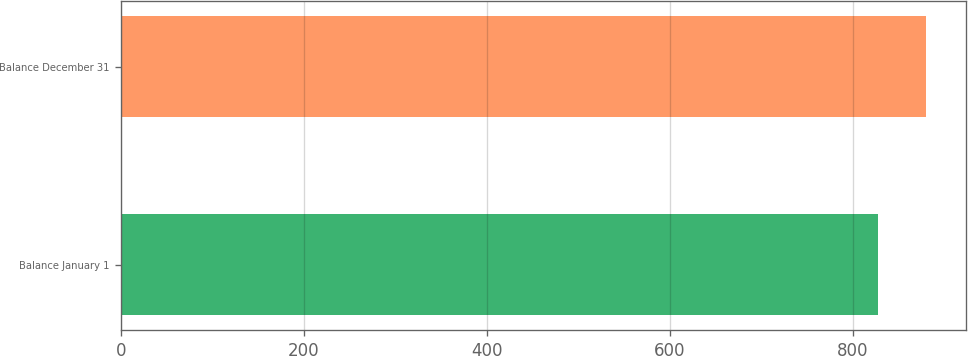<chart> <loc_0><loc_0><loc_500><loc_500><bar_chart><fcel>Balance January 1<fcel>Balance December 31<nl><fcel>828<fcel>880<nl></chart> 